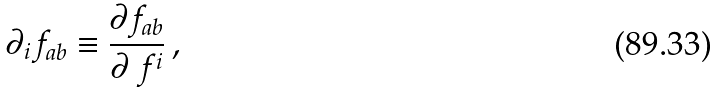Convert formula to latex. <formula><loc_0><loc_0><loc_500><loc_500>\partial _ { i } f _ { a b } \equiv \frac { \partial f _ { a b } } { \partial \ f ^ { i } } \, ,</formula> 